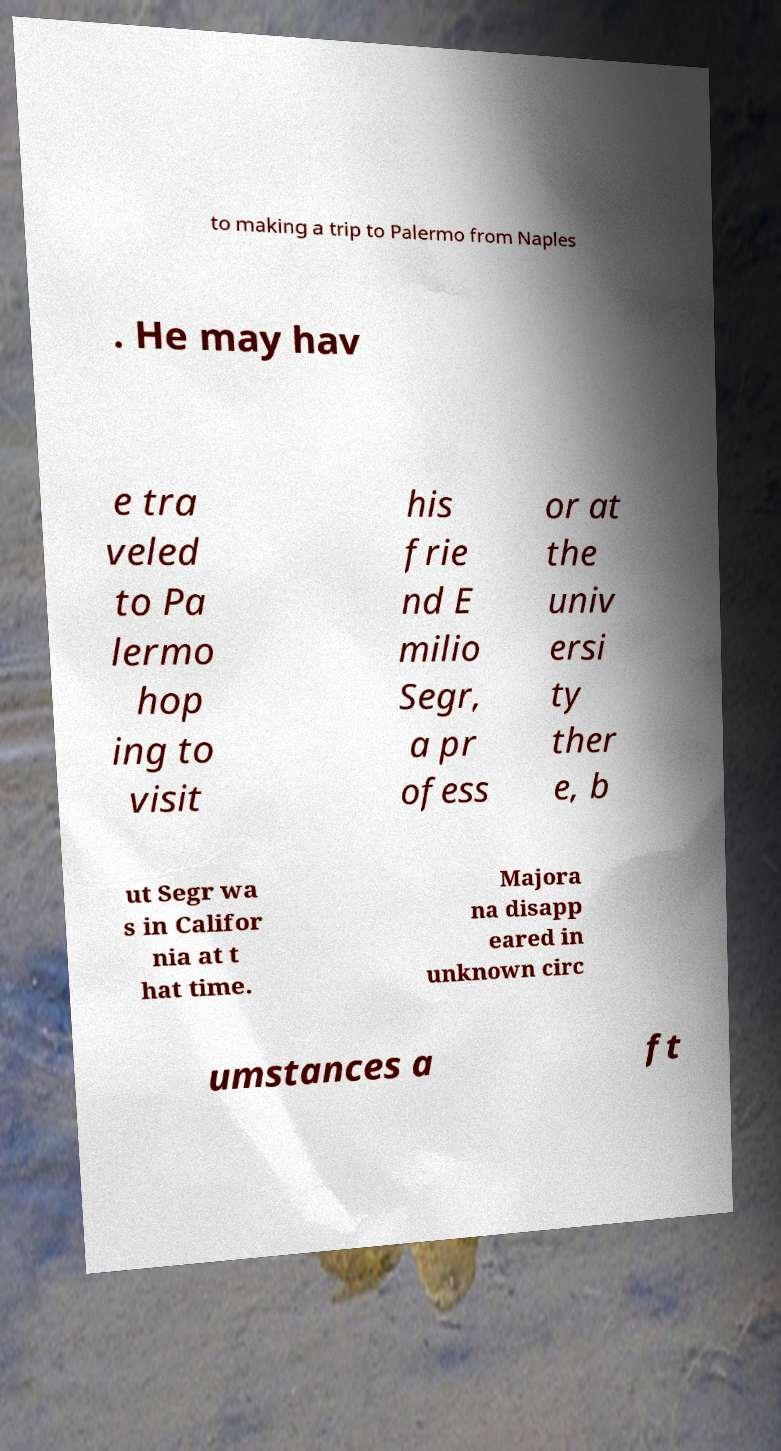Please read and relay the text visible in this image. What does it say? to making a trip to Palermo from Naples . He may hav e tra veled to Pa lermo hop ing to visit his frie nd E milio Segr, a pr ofess or at the univ ersi ty ther e, b ut Segr wa s in Califor nia at t hat time. Majora na disapp eared in unknown circ umstances a ft 